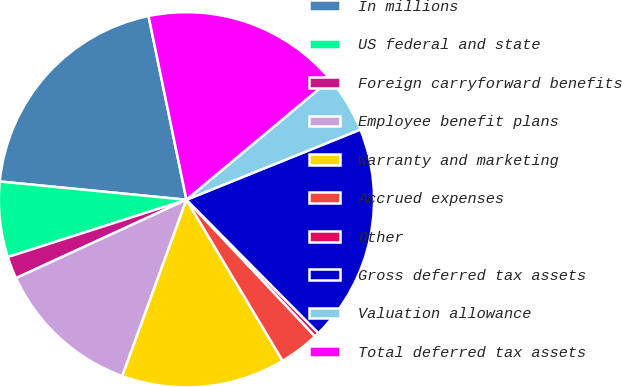<chart> <loc_0><loc_0><loc_500><loc_500><pie_chart><fcel>In millions<fcel>US federal and state<fcel>Foreign carryforward benefits<fcel>Employee benefit plans<fcel>Warranty and marketing<fcel>Accrued expenses<fcel>Other<fcel>Gross deferred tax assets<fcel>Valuation allowance<fcel>Total deferred tax assets<nl><fcel>20.21%<fcel>6.49%<fcel>1.92%<fcel>12.59%<fcel>14.12%<fcel>3.45%<fcel>0.4%<fcel>18.69%<fcel>4.97%<fcel>17.16%<nl></chart> 